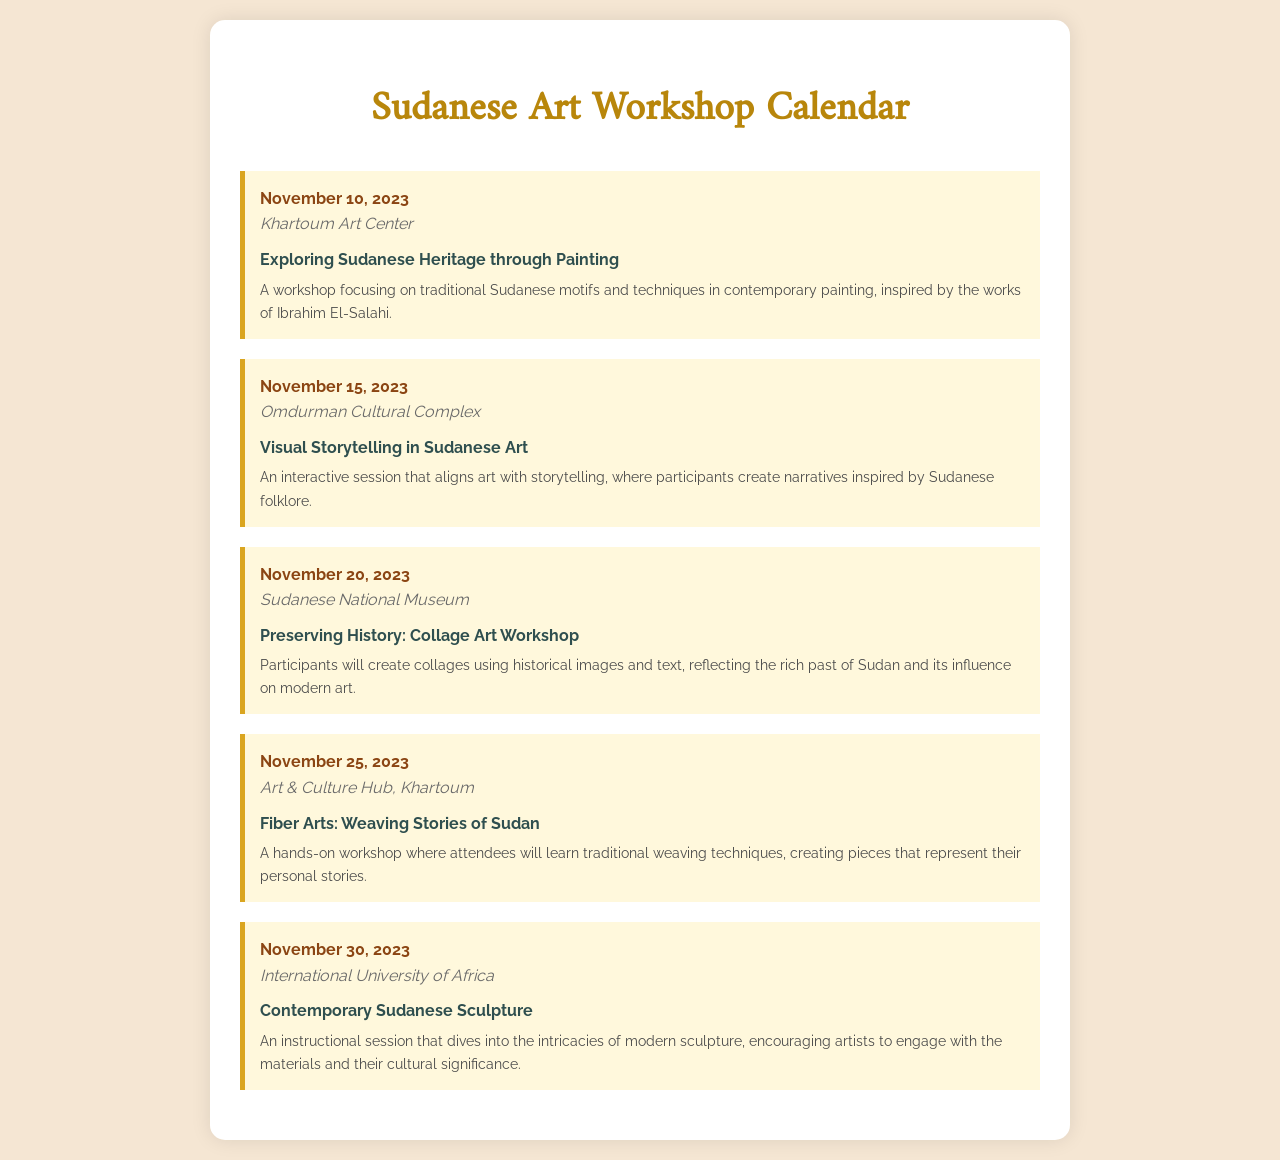What is the date of the first workshop? The first workshop is scheduled for November 10, 2023.
Answer: November 10, 2023 Where is the "Visual Storytelling in Sudanese Art" workshop held? The "Visual Storytelling in Sudanese Art" workshop takes place at the Omdurman Cultural Complex.
Answer: Omdurman Cultural Complex What theme is covered on November 25, 2023? The theme for November 25, 2023, is "Fiber Arts: Weaving Stories of Sudan."
Answer: Fiber Arts: Weaving Stories of Sudan Which workshop focuses on collage art? The workshop titled "Preserving History: Collage Art Workshop" focuses on collage art.
Answer: Preserving History: Collage Art Workshop How many workshops are scheduled in total? There are five workshops scheduled in total, as listed in the document.
Answer: Five What is the location for the contemporary sculpture session? The contemporary sculpture session is located at the International University of Africa.
Answer: International University of Africa Which theme involves traditional painting techniques? The workshop on November 10, 2023, explores "Exploring Sudanese Heritage through Painting."
Answer: Exploring Sudanese Heritage through Painting What kind of materials will be explored in the sculpture workshop? The sculpture workshop encourages artists to engage with materials and their cultural significance.
Answer: Materials and cultural significance What is the main focus of the "Fiber Arts" workshop? The main focus of the "Fiber Arts" workshop is traditional weaving techniques.
Answer: Traditional weaving techniques 